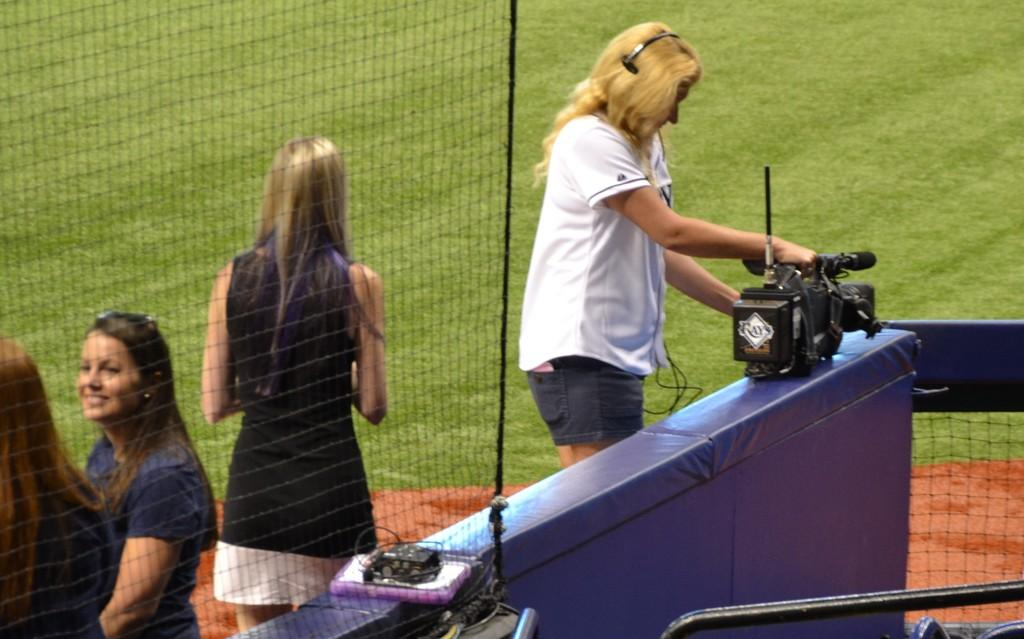What is the shape of the area where the image was taken? The image is taken in a round area. Can you describe the woman in the image? There is a woman wearing a white t-shirt in the image, and she is holding a camera. How many women are wearing blue dresses in the image? There are three women wearing blue dresses in the image. Where is the camera placed in the image? The camera is placed on a blue wall. What type of sack can be seen in the image? There is no sack present in the image. What scientific theory is being discussed by the women in the image? The image does not depict a discussion about any scientific theory. 